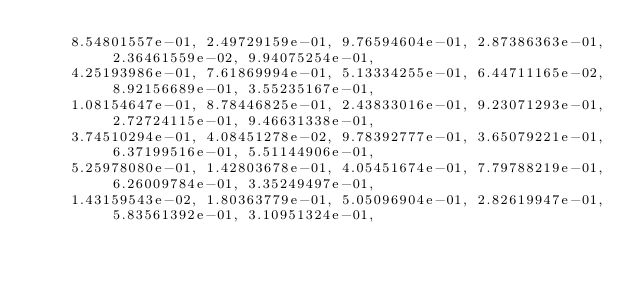Convert code to text. <code><loc_0><loc_0><loc_500><loc_500><_Cuda_>    8.54801557e-01, 2.49729159e-01, 9.76594604e-01, 2.87386363e-01, 2.36461559e-02, 9.94075254e-01,
    4.25193986e-01, 7.61869994e-01, 5.13334255e-01, 6.44711165e-02, 8.92156689e-01, 3.55235167e-01,
    1.08154647e-01, 8.78446825e-01, 2.43833016e-01, 9.23071293e-01, 2.72724115e-01, 9.46631338e-01,
    3.74510294e-01, 4.08451278e-02, 9.78392777e-01, 3.65079221e-01, 6.37199516e-01, 5.51144906e-01,
    5.25978080e-01, 1.42803678e-01, 4.05451674e-01, 7.79788219e-01, 6.26009784e-01, 3.35249497e-01,
    1.43159543e-02, 1.80363779e-01, 5.05096904e-01, 2.82619947e-01, 5.83561392e-01, 3.10951324e-01,</code> 